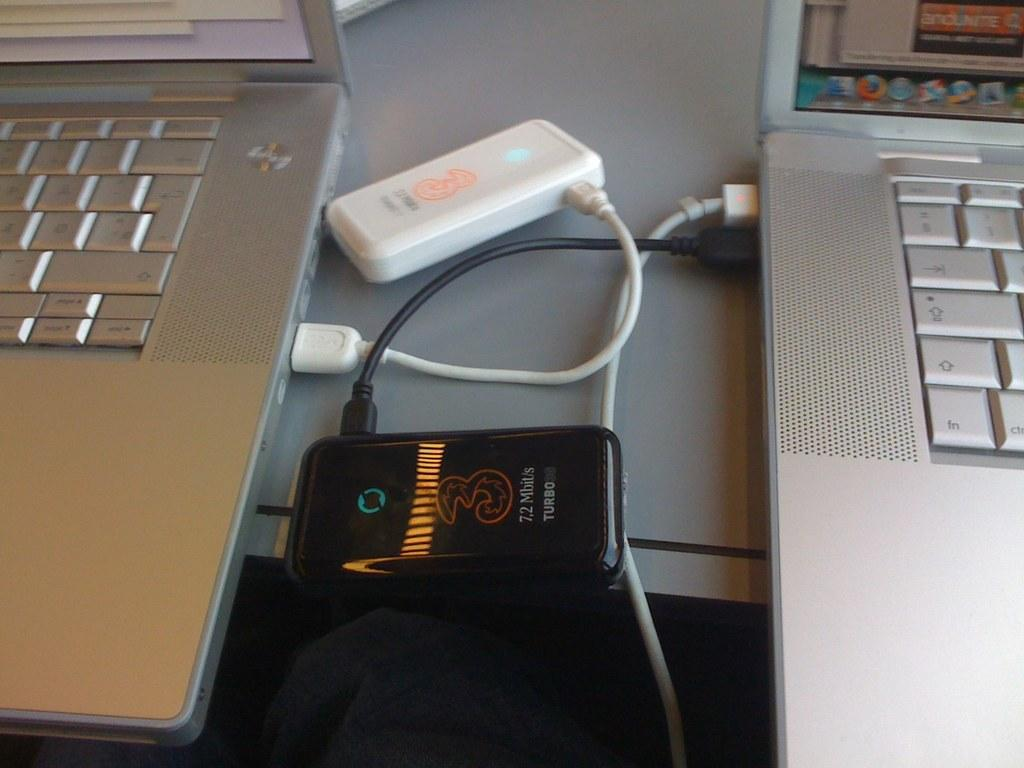How many laptops are visible on the table in the image? There are two laptops on the table in the image. What is the relationship between the laptops and the device with wires? The laptops are connected to a device with wires. Can you describe the screen in the top right corner of the image? There is a screen with icons in the top right corner of the image. How many kittens can be seen attempting to fall off the table in the image? There are no kittens present in the image, and therefore no such activity can be observed. 